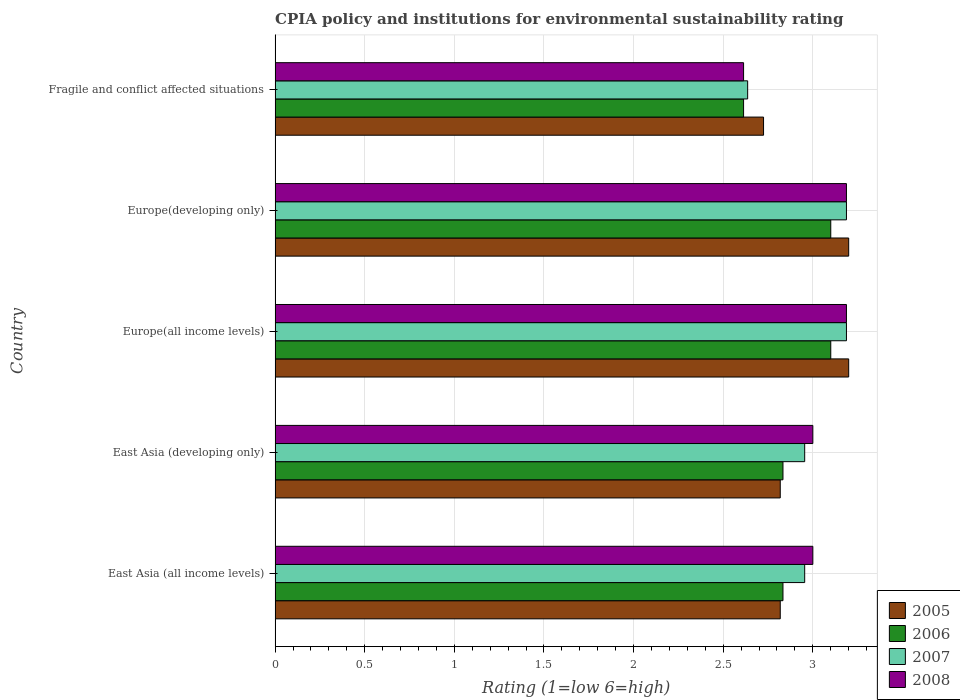How many groups of bars are there?
Provide a short and direct response. 5. Are the number of bars on each tick of the Y-axis equal?
Your response must be concise. Yes. How many bars are there on the 3rd tick from the bottom?
Provide a short and direct response. 4. What is the label of the 2nd group of bars from the top?
Your response must be concise. Europe(developing only). What is the CPIA rating in 2006 in Fragile and conflict affected situations?
Keep it short and to the point. 2.61. Across all countries, what is the maximum CPIA rating in 2006?
Offer a very short reply. 3.1. Across all countries, what is the minimum CPIA rating in 2006?
Provide a short and direct response. 2.61. In which country was the CPIA rating in 2007 maximum?
Provide a succinct answer. Europe(all income levels). In which country was the CPIA rating in 2005 minimum?
Offer a terse response. Fragile and conflict affected situations. What is the total CPIA rating in 2008 in the graph?
Keep it short and to the point. 14.99. What is the difference between the CPIA rating in 2007 in East Asia (developing only) and that in Fragile and conflict affected situations?
Provide a succinct answer. 0.32. What is the difference between the CPIA rating in 2005 in Europe(developing only) and the CPIA rating in 2008 in East Asia (all income levels)?
Ensure brevity in your answer.  0.2. What is the average CPIA rating in 2008 per country?
Your answer should be compact. 3. What is the difference between the CPIA rating in 2005 and CPIA rating in 2006 in East Asia (developing only)?
Your response must be concise. -0.02. What is the ratio of the CPIA rating in 2005 in East Asia (all income levels) to that in Europe(developing only)?
Offer a very short reply. 0.88. Is the CPIA rating in 2007 in East Asia (all income levels) less than that in Europe(developing only)?
Keep it short and to the point. Yes. Is the difference between the CPIA rating in 2005 in East Asia (developing only) and Fragile and conflict affected situations greater than the difference between the CPIA rating in 2006 in East Asia (developing only) and Fragile and conflict affected situations?
Your answer should be very brief. No. What is the difference between the highest and the second highest CPIA rating in 2006?
Make the answer very short. 0. What is the difference between the highest and the lowest CPIA rating in 2005?
Offer a very short reply. 0.48. In how many countries, is the CPIA rating in 2008 greater than the average CPIA rating in 2008 taken over all countries?
Provide a short and direct response. 4. Is the sum of the CPIA rating in 2005 in Europe(developing only) and Fragile and conflict affected situations greater than the maximum CPIA rating in 2008 across all countries?
Give a very brief answer. Yes. Is it the case that in every country, the sum of the CPIA rating in 2008 and CPIA rating in 2006 is greater than the sum of CPIA rating in 2007 and CPIA rating in 2005?
Provide a succinct answer. No. Are all the bars in the graph horizontal?
Offer a terse response. Yes. What is the difference between two consecutive major ticks on the X-axis?
Keep it short and to the point. 0.5. Are the values on the major ticks of X-axis written in scientific E-notation?
Provide a short and direct response. No. Does the graph contain any zero values?
Provide a succinct answer. No. Does the graph contain grids?
Your answer should be compact. Yes. Where does the legend appear in the graph?
Your answer should be very brief. Bottom right. How many legend labels are there?
Provide a short and direct response. 4. How are the legend labels stacked?
Offer a terse response. Vertical. What is the title of the graph?
Provide a short and direct response. CPIA policy and institutions for environmental sustainability rating. Does "1970" appear as one of the legend labels in the graph?
Offer a terse response. No. What is the label or title of the Y-axis?
Your answer should be very brief. Country. What is the Rating (1=low 6=high) in 2005 in East Asia (all income levels)?
Offer a terse response. 2.82. What is the Rating (1=low 6=high) of 2006 in East Asia (all income levels)?
Offer a very short reply. 2.83. What is the Rating (1=low 6=high) in 2007 in East Asia (all income levels)?
Make the answer very short. 2.95. What is the Rating (1=low 6=high) of 2005 in East Asia (developing only)?
Your answer should be very brief. 2.82. What is the Rating (1=low 6=high) in 2006 in East Asia (developing only)?
Your response must be concise. 2.83. What is the Rating (1=low 6=high) in 2007 in East Asia (developing only)?
Provide a short and direct response. 2.95. What is the Rating (1=low 6=high) of 2006 in Europe(all income levels)?
Your answer should be very brief. 3.1. What is the Rating (1=low 6=high) in 2007 in Europe(all income levels)?
Make the answer very short. 3.19. What is the Rating (1=low 6=high) in 2008 in Europe(all income levels)?
Provide a short and direct response. 3.19. What is the Rating (1=low 6=high) in 2007 in Europe(developing only)?
Your answer should be very brief. 3.19. What is the Rating (1=low 6=high) in 2008 in Europe(developing only)?
Provide a succinct answer. 3.19. What is the Rating (1=low 6=high) of 2005 in Fragile and conflict affected situations?
Provide a short and direct response. 2.73. What is the Rating (1=low 6=high) in 2006 in Fragile and conflict affected situations?
Provide a short and direct response. 2.61. What is the Rating (1=low 6=high) in 2007 in Fragile and conflict affected situations?
Provide a succinct answer. 2.64. What is the Rating (1=low 6=high) of 2008 in Fragile and conflict affected situations?
Your answer should be compact. 2.61. Across all countries, what is the maximum Rating (1=low 6=high) of 2007?
Make the answer very short. 3.19. Across all countries, what is the maximum Rating (1=low 6=high) of 2008?
Provide a short and direct response. 3.19. Across all countries, what is the minimum Rating (1=low 6=high) of 2005?
Make the answer very short. 2.73. Across all countries, what is the minimum Rating (1=low 6=high) of 2006?
Your response must be concise. 2.61. Across all countries, what is the minimum Rating (1=low 6=high) in 2007?
Your answer should be very brief. 2.64. Across all countries, what is the minimum Rating (1=low 6=high) in 2008?
Your answer should be very brief. 2.61. What is the total Rating (1=low 6=high) in 2005 in the graph?
Provide a succinct answer. 14.76. What is the total Rating (1=low 6=high) in 2006 in the graph?
Provide a short and direct response. 14.48. What is the total Rating (1=low 6=high) of 2007 in the graph?
Your answer should be compact. 14.92. What is the total Rating (1=low 6=high) of 2008 in the graph?
Give a very brief answer. 14.99. What is the difference between the Rating (1=low 6=high) in 2005 in East Asia (all income levels) and that in East Asia (developing only)?
Provide a succinct answer. 0. What is the difference between the Rating (1=low 6=high) of 2007 in East Asia (all income levels) and that in East Asia (developing only)?
Provide a succinct answer. 0. What is the difference between the Rating (1=low 6=high) of 2005 in East Asia (all income levels) and that in Europe(all income levels)?
Make the answer very short. -0.38. What is the difference between the Rating (1=low 6=high) of 2006 in East Asia (all income levels) and that in Europe(all income levels)?
Offer a very short reply. -0.27. What is the difference between the Rating (1=low 6=high) in 2007 in East Asia (all income levels) and that in Europe(all income levels)?
Provide a short and direct response. -0.23. What is the difference between the Rating (1=low 6=high) in 2008 in East Asia (all income levels) and that in Europe(all income levels)?
Keep it short and to the point. -0.19. What is the difference between the Rating (1=low 6=high) of 2005 in East Asia (all income levels) and that in Europe(developing only)?
Make the answer very short. -0.38. What is the difference between the Rating (1=low 6=high) in 2006 in East Asia (all income levels) and that in Europe(developing only)?
Keep it short and to the point. -0.27. What is the difference between the Rating (1=low 6=high) of 2007 in East Asia (all income levels) and that in Europe(developing only)?
Your answer should be compact. -0.23. What is the difference between the Rating (1=low 6=high) of 2008 in East Asia (all income levels) and that in Europe(developing only)?
Give a very brief answer. -0.19. What is the difference between the Rating (1=low 6=high) of 2005 in East Asia (all income levels) and that in Fragile and conflict affected situations?
Your answer should be very brief. 0.09. What is the difference between the Rating (1=low 6=high) of 2006 in East Asia (all income levels) and that in Fragile and conflict affected situations?
Keep it short and to the point. 0.22. What is the difference between the Rating (1=low 6=high) of 2007 in East Asia (all income levels) and that in Fragile and conflict affected situations?
Make the answer very short. 0.32. What is the difference between the Rating (1=low 6=high) in 2008 in East Asia (all income levels) and that in Fragile and conflict affected situations?
Ensure brevity in your answer.  0.39. What is the difference between the Rating (1=low 6=high) in 2005 in East Asia (developing only) and that in Europe(all income levels)?
Your response must be concise. -0.38. What is the difference between the Rating (1=low 6=high) of 2006 in East Asia (developing only) and that in Europe(all income levels)?
Keep it short and to the point. -0.27. What is the difference between the Rating (1=low 6=high) of 2007 in East Asia (developing only) and that in Europe(all income levels)?
Give a very brief answer. -0.23. What is the difference between the Rating (1=low 6=high) of 2008 in East Asia (developing only) and that in Europe(all income levels)?
Offer a terse response. -0.19. What is the difference between the Rating (1=low 6=high) in 2005 in East Asia (developing only) and that in Europe(developing only)?
Keep it short and to the point. -0.38. What is the difference between the Rating (1=low 6=high) in 2006 in East Asia (developing only) and that in Europe(developing only)?
Make the answer very short. -0.27. What is the difference between the Rating (1=low 6=high) in 2007 in East Asia (developing only) and that in Europe(developing only)?
Offer a very short reply. -0.23. What is the difference between the Rating (1=low 6=high) of 2008 in East Asia (developing only) and that in Europe(developing only)?
Make the answer very short. -0.19. What is the difference between the Rating (1=low 6=high) in 2005 in East Asia (developing only) and that in Fragile and conflict affected situations?
Provide a succinct answer. 0.09. What is the difference between the Rating (1=low 6=high) of 2006 in East Asia (developing only) and that in Fragile and conflict affected situations?
Your answer should be compact. 0.22. What is the difference between the Rating (1=low 6=high) in 2007 in East Asia (developing only) and that in Fragile and conflict affected situations?
Keep it short and to the point. 0.32. What is the difference between the Rating (1=low 6=high) in 2008 in East Asia (developing only) and that in Fragile and conflict affected situations?
Give a very brief answer. 0.39. What is the difference between the Rating (1=low 6=high) of 2005 in Europe(all income levels) and that in Europe(developing only)?
Provide a succinct answer. 0. What is the difference between the Rating (1=low 6=high) of 2007 in Europe(all income levels) and that in Europe(developing only)?
Your answer should be very brief. 0. What is the difference between the Rating (1=low 6=high) of 2008 in Europe(all income levels) and that in Europe(developing only)?
Make the answer very short. 0. What is the difference between the Rating (1=low 6=high) in 2005 in Europe(all income levels) and that in Fragile and conflict affected situations?
Make the answer very short. 0.47. What is the difference between the Rating (1=low 6=high) in 2006 in Europe(all income levels) and that in Fragile and conflict affected situations?
Your response must be concise. 0.49. What is the difference between the Rating (1=low 6=high) in 2007 in Europe(all income levels) and that in Fragile and conflict affected situations?
Your response must be concise. 0.55. What is the difference between the Rating (1=low 6=high) in 2008 in Europe(all income levels) and that in Fragile and conflict affected situations?
Provide a short and direct response. 0.57. What is the difference between the Rating (1=low 6=high) in 2005 in Europe(developing only) and that in Fragile and conflict affected situations?
Give a very brief answer. 0.47. What is the difference between the Rating (1=low 6=high) in 2006 in Europe(developing only) and that in Fragile and conflict affected situations?
Your answer should be very brief. 0.49. What is the difference between the Rating (1=low 6=high) of 2007 in Europe(developing only) and that in Fragile and conflict affected situations?
Make the answer very short. 0.55. What is the difference between the Rating (1=low 6=high) in 2008 in Europe(developing only) and that in Fragile and conflict affected situations?
Offer a very short reply. 0.57. What is the difference between the Rating (1=low 6=high) in 2005 in East Asia (all income levels) and the Rating (1=low 6=high) in 2006 in East Asia (developing only)?
Offer a very short reply. -0.02. What is the difference between the Rating (1=low 6=high) in 2005 in East Asia (all income levels) and the Rating (1=low 6=high) in 2007 in East Asia (developing only)?
Your answer should be very brief. -0.14. What is the difference between the Rating (1=low 6=high) of 2005 in East Asia (all income levels) and the Rating (1=low 6=high) of 2008 in East Asia (developing only)?
Make the answer very short. -0.18. What is the difference between the Rating (1=low 6=high) of 2006 in East Asia (all income levels) and the Rating (1=low 6=high) of 2007 in East Asia (developing only)?
Your answer should be very brief. -0.12. What is the difference between the Rating (1=low 6=high) in 2006 in East Asia (all income levels) and the Rating (1=low 6=high) in 2008 in East Asia (developing only)?
Your answer should be compact. -0.17. What is the difference between the Rating (1=low 6=high) in 2007 in East Asia (all income levels) and the Rating (1=low 6=high) in 2008 in East Asia (developing only)?
Offer a terse response. -0.05. What is the difference between the Rating (1=low 6=high) of 2005 in East Asia (all income levels) and the Rating (1=low 6=high) of 2006 in Europe(all income levels)?
Your answer should be compact. -0.28. What is the difference between the Rating (1=low 6=high) of 2005 in East Asia (all income levels) and the Rating (1=low 6=high) of 2007 in Europe(all income levels)?
Your answer should be compact. -0.37. What is the difference between the Rating (1=low 6=high) in 2005 in East Asia (all income levels) and the Rating (1=low 6=high) in 2008 in Europe(all income levels)?
Offer a terse response. -0.37. What is the difference between the Rating (1=low 6=high) of 2006 in East Asia (all income levels) and the Rating (1=low 6=high) of 2007 in Europe(all income levels)?
Ensure brevity in your answer.  -0.35. What is the difference between the Rating (1=low 6=high) of 2006 in East Asia (all income levels) and the Rating (1=low 6=high) of 2008 in Europe(all income levels)?
Your response must be concise. -0.35. What is the difference between the Rating (1=low 6=high) in 2007 in East Asia (all income levels) and the Rating (1=low 6=high) in 2008 in Europe(all income levels)?
Provide a short and direct response. -0.23. What is the difference between the Rating (1=low 6=high) of 2005 in East Asia (all income levels) and the Rating (1=low 6=high) of 2006 in Europe(developing only)?
Make the answer very short. -0.28. What is the difference between the Rating (1=low 6=high) of 2005 in East Asia (all income levels) and the Rating (1=low 6=high) of 2007 in Europe(developing only)?
Your response must be concise. -0.37. What is the difference between the Rating (1=low 6=high) of 2005 in East Asia (all income levels) and the Rating (1=low 6=high) of 2008 in Europe(developing only)?
Keep it short and to the point. -0.37. What is the difference between the Rating (1=low 6=high) of 2006 in East Asia (all income levels) and the Rating (1=low 6=high) of 2007 in Europe(developing only)?
Your response must be concise. -0.35. What is the difference between the Rating (1=low 6=high) in 2006 in East Asia (all income levels) and the Rating (1=low 6=high) in 2008 in Europe(developing only)?
Your answer should be compact. -0.35. What is the difference between the Rating (1=low 6=high) in 2007 in East Asia (all income levels) and the Rating (1=low 6=high) in 2008 in Europe(developing only)?
Ensure brevity in your answer.  -0.23. What is the difference between the Rating (1=low 6=high) in 2005 in East Asia (all income levels) and the Rating (1=low 6=high) in 2006 in Fragile and conflict affected situations?
Your answer should be very brief. 0.2. What is the difference between the Rating (1=low 6=high) of 2005 in East Asia (all income levels) and the Rating (1=low 6=high) of 2007 in Fragile and conflict affected situations?
Ensure brevity in your answer.  0.18. What is the difference between the Rating (1=low 6=high) of 2005 in East Asia (all income levels) and the Rating (1=low 6=high) of 2008 in Fragile and conflict affected situations?
Your answer should be compact. 0.2. What is the difference between the Rating (1=low 6=high) of 2006 in East Asia (all income levels) and the Rating (1=low 6=high) of 2007 in Fragile and conflict affected situations?
Make the answer very short. 0.2. What is the difference between the Rating (1=low 6=high) in 2006 in East Asia (all income levels) and the Rating (1=low 6=high) in 2008 in Fragile and conflict affected situations?
Offer a very short reply. 0.22. What is the difference between the Rating (1=low 6=high) of 2007 in East Asia (all income levels) and the Rating (1=low 6=high) of 2008 in Fragile and conflict affected situations?
Provide a succinct answer. 0.34. What is the difference between the Rating (1=low 6=high) of 2005 in East Asia (developing only) and the Rating (1=low 6=high) of 2006 in Europe(all income levels)?
Ensure brevity in your answer.  -0.28. What is the difference between the Rating (1=low 6=high) of 2005 in East Asia (developing only) and the Rating (1=low 6=high) of 2007 in Europe(all income levels)?
Your answer should be very brief. -0.37. What is the difference between the Rating (1=low 6=high) of 2005 in East Asia (developing only) and the Rating (1=low 6=high) of 2008 in Europe(all income levels)?
Keep it short and to the point. -0.37. What is the difference between the Rating (1=low 6=high) of 2006 in East Asia (developing only) and the Rating (1=low 6=high) of 2007 in Europe(all income levels)?
Your answer should be very brief. -0.35. What is the difference between the Rating (1=low 6=high) of 2006 in East Asia (developing only) and the Rating (1=low 6=high) of 2008 in Europe(all income levels)?
Offer a terse response. -0.35. What is the difference between the Rating (1=low 6=high) of 2007 in East Asia (developing only) and the Rating (1=low 6=high) of 2008 in Europe(all income levels)?
Give a very brief answer. -0.23. What is the difference between the Rating (1=low 6=high) in 2005 in East Asia (developing only) and the Rating (1=low 6=high) in 2006 in Europe(developing only)?
Your answer should be very brief. -0.28. What is the difference between the Rating (1=low 6=high) in 2005 in East Asia (developing only) and the Rating (1=low 6=high) in 2007 in Europe(developing only)?
Your answer should be compact. -0.37. What is the difference between the Rating (1=low 6=high) of 2005 in East Asia (developing only) and the Rating (1=low 6=high) of 2008 in Europe(developing only)?
Offer a very short reply. -0.37. What is the difference between the Rating (1=low 6=high) of 2006 in East Asia (developing only) and the Rating (1=low 6=high) of 2007 in Europe(developing only)?
Provide a succinct answer. -0.35. What is the difference between the Rating (1=low 6=high) in 2006 in East Asia (developing only) and the Rating (1=low 6=high) in 2008 in Europe(developing only)?
Keep it short and to the point. -0.35. What is the difference between the Rating (1=low 6=high) in 2007 in East Asia (developing only) and the Rating (1=low 6=high) in 2008 in Europe(developing only)?
Provide a succinct answer. -0.23. What is the difference between the Rating (1=low 6=high) of 2005 in East Asia (developing only) and the Rating (1=low 6=high) of 2006 in Fragile and conflict affected situations?
Your answer should be compact. 0.2. What is the difference between the Rating (1=low 6=high) in 2005 in East Asia (developing only) and the Rating (1=low 6=high) in 2007 in Fragile and conflict affected situations?
Give a very brief answer. 0.18. What is the difference between the Rating (1=low 6=high) of 2005 in East Asia (developing only) and the Rating (1=low 6=high) of 2008 in Fragile and conflict affected situations?
Your answer should be very brief. 0.2. What is the difference between the Rating (1=low 6=high) of 2006 in East Asia (developing only) and the Rating (1=low 6=high) of 2007 in Fragile and conflict affected situations?
Offer a terse response. 0.2. What is the difference between the Rating (1=low 6=high) in 2006 in East Asia (developing only) and the Rating (1=low 6=high) in 2008 in Fragile and conflict affected situations?
Ensure brevity in your answer.  0.22. What is the difference between the Rating (1=low 6=high) in 2007 in East Asia (developing only) and the Rating (1=low 6=high) in 2008 in Fragile and conflict affected situations?
Your response must be concise. 0.34. What is the difference between the Rating (1=low 6=high) of 2005 in Europe(all income levels) and the Rating (1=low 6=high) of 2007 in Europe(developing only)?
Make the answer very short. 0.01. What is the difference between the Rating (1=low 6=high) in 2005 in Europe(all income levels) and the Rating (1=low 6=high) in 2008 in Europe(developing only)?
Offer a terse response. 0.01. What is the difference between the Rating (1=low 6=high) in 2006 in Europe(all income levels) and the Rating (1=low 6=high) in 2007 in Europe(developing only)?
Provide a short and direct response. -0.09. What is the difference between the Rating (1=low 6=high) of 2006 in Europe(all income levels) and the Rating (1=low 6=high) of 2008 in Europe(developing only)?
Provide a succinct answer. -0.09. What is the difference between the Rating (1=low 6=high) of 2007 in Europe(all income levels) and the Rating (1=low 6=high) of 2008 in Europe(developing only)?
Make the answer very short. 0. What is the difference between the Rating (1=low 6=high) of 2005 in Europe(all income levels) and the Rating (1=low 6=high) of 2006 in Fragile and conflict affected situations?
Your answer should be very brief. 0.59. What is the difference between the Rating (1=low 6=high) of 2005 in Europe(all income levels) and the Rating (1=low 6=high) of 2007 in Fragile and conflict affected situations?
Provide a succinct answer. 0.56. What is the difference between the Rating (1=low 6=high) in 2005 in Europe(all income levels) and the Rating (1=low 6=high) in 2008 in Fragile and conflict affected situations?
Offer a terse response. 0.59. What is the difference between the Rating (1=low 6=high) in 2006 in Europe(all income levels) and the Rating (1=low 6=high) in 2007 in Fragile and conflict affected situations?
Offer a very short reply. 0.46. What is the difference between the Rating (1=low 6=high) in 2006 in Europe(all income levels) and the Rating (1=low 6=high) in 2008 in Fragile and conflict affected situations?
Ensure brevity in your answer.  0.49. What is the difference between the Rating (1=low 6=high) in 2007 in Europe(all income levels) and the Rating (1=low 6=high) in 2008 in Fragile and conflict affected situations?
Provide a short and direct response. 0.57. What is the difference between the Rating (1=low 6=high) of 2005 in Europe(developing only) and the Rating (1=low 6=high) of 2006 in Fragile and conflict affected situations?
Your answer should be very brief. 0.59. What is the difference between the Rating (1=low 6=high) in 2005 in Europe(developing only) and the Rating (1=low 6=high) in 2007 in Fragile and conflict affected situations?
Keep it short and to the point. 0.56. What is the difference between the Rating (1=low 6=high) in 2005 in Europe(developing only) and the Rating (1=low 6=high) in 2008 in Fragile and conflict affected situations?
Provide a short and direct response. 0.59. What is the difference between the Rating (1=low 6=high) in 2006 in Europe(developing only) and the Rating (1=low 6=high) in 2007 in Fragile and conflict affected situations?
Offer a terse response. 0.46. What is the difference between the Rating (1=low 6=high) of 2006 in Europe(developing only) and the Rating (1=low 6=high) of 2008 in Fragile and conflict affected situations?
Ensure brevity in your answer.  0.49. What is the difference between the Rating (1=low 6=high) of 2007 in Europe(developing only) and the Rating (1=low 6=high) of 2008 in Fragile and conflict affected situations?
Offer a very short reply. 0.57. What is the average Rating (1=low 6=high) of 2005 per country?
Ensure brevity in your answer.  2.95. What is the average Rating (1=low 6=high) in 2006 per country?
Provide a short and direct response. 2.9. What is the average Rating (1=low 6=high) in 2007 per country?
Provide a succinct answer. 2.98. What is the average Rating (1=low 6=high) in 2008 per country?
Offer a very short reply. 3. What is the difference between the Rating (1=low 6=high) of 2005 and Rating (1=low 6=high) of 2006 in East Asia (all income levels)?
Your answer should be very brief. -0.02. What is the difference between the Rating (1=low 6=high) of 2005 and Rating (1=low 6=high) of 2007 in East Asia (all income levels)?
Offer a terse response. -0.14. What is the difference between the Rating (1=low 6=high) in 2005 and Rating (1=low 6=high) in 2008 in East Asia (all income levels)?
Keep it short and to the point. -0.18. What is the difference between the Rating (1=low 6=high) of 2006 and Rating (1=low 6=high) of 2007 in East Asia (all income levels)?
Give a very brief answer. -0.12. What is the difference between the Rating (1=low 6=high) of 2007 and Rating (1=low 6=high) of 2008 in East Asia (all income levels)?
Make the answer very short. -0.05. What is the difference between the Rating (1=low 6=high) in 2005 and Rating (1=low 6=high) in 2006 in East Asia (developing only)?
Your answer should be very brief. -0.02. What is the difference between the Rating (1=low 6=high) in 2005 and Rating (1=low 6=high) in 2007 in East Asia (developing only)?
Give a very brief answer. -0.14. What is the difference between the Rating (1=low 6=high) in 2005 and Rating (1=low 6=high) in 2008 in East Asia (developing only)?
Provide a short and direct response. -0.18. What is the difference between the Rating (1=low 6=high) in 2006 and Rating (1=low 6=high) in 2007 in East Asia (developing only)?
Give a very brief answer. -0.12. What is the difference between the Rating (1=low 6=high) of 2006 and Rating (1=low 6=high) of 2008 in East Asia (developing only)?
Your answer should be compact. -0.17. What is the difference between the Rating (1=low 6=high) in 2007 and Rating (1=low 6=high) in 2008 in East Asia (developing only)?
Give a very brief answer. -0.05. What is the difference between the Rating (1=low 6=high) of 2005 and Rating (1=low 6=high) of 2006 in Europe(all income levels)?
Give a very brief answer. 0.1. What is the difference between the Rating (1=low 6=high) in 2005 and Rating (1=low 6=high) in 2007 in Europe(all income levels)?
Keep it short and to the point. 0.01. What is the difference between the Rating (1=low 6=high) in 2005 and Rating (1=low 6=high) in 2008 in Europe(all income levels)?
Offer a very short reply. 0.01. What is the difference between the Rating (1=low 6=high) of 2006 and Rating (1=low 6=high) of 2007 in Europe(all income levels)?
Provide a succinct answer. -0.09. What is the difference between the Rating (1=low 6=high) in 2006 and Rating (1=low 6=high) in 2008 in Europe(all income levels)?
Make the answer very short. -0.09. What is the difference between the Rating (1=low 6=high) of 2007 and Rating (1=low 6=high) of 2008 in Europe(all income levels)?
Ensure brevity in your answer.  0. What is the difference between the Rating (1=low 6=high) of 2005 and Rating (1=low 6=high) of 2007 in Europe(developing only)?
Make the answer very short. 0.01. What is the difference between the Rating (1=low 6=high) of 2005 and Rating (1=low 6=high) of 2008 in Europe(developing only)?
Keep it short and to the point. 0.01. What is the difference between the Rating (1=low 6=high) in 2006 and Rating (1=low 6=high) in 2007 in Europe(developing only)?
Provide a short and direct response. -0.09. What is the difference between the Rating (1=low 6=high) in 2006 and Rating (1=low 6=high) in 2008 in Europe(developing only)?
Offer a very short reply. -0.09. What is the difference between the Rating (1=low 6=high) of 2007 and Rating (1=low 6=high) of 2008 in Europe(developing only)?
Keep it short and to the point. 0. What is the difference between the Rating (1=low 6=high) of 2005 and Rating (1=low 6=high) of 2006 in Fragile and conflict affected situations?
Your answer should be compact. 0.11. What is the difference between the Rating (1=low 6=high) in 2005 and Rating (1=low 6=high) in 2007 in Fragile and conflict affected situations?
Your response must be concise. 0.09. What is the difference between the Rating (1=low 6=high) in 2005 and Rating (1=low 6=high) in 2008 in Fragile and conflict affected situations?
Provide a short and direct response. 0.11. What is the difference between the Rating (1=low 6=high) in 2006 and Rating (1=low 6=high) in 2007 in Fragile and conflict affected situations?
Offer a very short reply. -0.02. What is the difference between the Rating (1=low 6=high) of 2006 and Rating (1=low 6=high) of 2008 in Fragile and conflict affected situations?
Keep it short and to the point. 0. What is the difference between the Rating (1=low 6=high) in 2007 and Rating (1=low 6=high) in 2008 in Fragile and conflict affected situations?
Keep it short and to the point. 0.02. What is the ratio of the Rating (1=low 6=high) of 2005 in East Asia (all income levels) to that in East Asia (developing only)?
Make the answer very short. 1. What is the ratio of the Rating (1=low 6=high) of 2006 in East Asia (all income levels) to that in East Asia (developing only)?
Make the answer very short. 1. What is the ratio of the Rating (1=low 6=high) of 2005 in East Asia (all income levels) to that in Europe(all income levels)?
Offer a very short reply. 0.88. What is the ratio of the Rating (1=low 6=high) in 2006 in East Asia (all income levels) to that in Europe(all income levels)?
Provide a short and direct response. 0.91. What is the ratio of the Rating (1=low 6=high) in 2007 in East Asia (all income levels) to that in Europe(all income levels)?
Your answer should be very brief. 0.93. What is the ratio of the Rating (1=low 6=high) in 2005 in East Asia (all income levels) to that in Europe(developing only)?
Offer a terse response. 0.88. What is the ratio of the Rating (1=low 6=high) of 2006 in East Asia (all income levels) to that in Europe(developing only)?
Offer a terse response. 0.91. What is the ratio of the Rating (1=low 6=high) of 2007 in East Asia (all income levels) to that in Europe(developing only)?
Offer a very short reply. 0.93. What is the ratio of the Rating (1=low 6=high) in 2008 in East Asia (all income levels) to that in Europe(developing only)?
Offer a very short reply. 0.94. What is the ratio of the Rating (1=low 6=high) in 2005 in East Asia (all income levels) to that in Fragile and conflict affected situations?
Your answer should be compact. 1.03. What is the ratio of the Rating (1=low 6=high) of 2006 in East Asia (all income levels) to that in Fragile and conflict affected situations?
Provide a succinct answer. 1.08. What is the ratio of the Rating (1=low 6=high) in 2007 in East Asia (all income levels) to that in Fragile and conflict affected situations?
Give a very brief answer. 1.12. What is the ratio of the Rating (1=low 6=high) of 2008 in East Asia (all income levels) to that in Fragile and conflict affected situations?
Your answer should be compact. 1.15. What is the ratio of the Rating (1=low 6=high) in 2005 in East Asia (developing only) to that in Europe(all income levels)?
Ensure brevity in your answer.  0.88. What is the ratio of the Rating (1=low 6=high) of 2006 in East Asia (developing only) to that in Europe(all income levels)?
Provide a succinct answer. 0.91. What is the ratio of the Rating (1=low 6=high) in 2007 in East Asia (developing only) to that in Europe(all income levels)?
Provide a succinct answer. 0.93. What is the ratio of the Rating (1=low 6=high) of 2005 in East Asia (developing only) to that in Europe(developing only)?
Your answer should be very brief. 0.88. What is the ratio of the Rating (1=low 6=high) of 2006 in East Asia (developing only) to that in Europe(developing only)?
Your response must be concise. 0.91. What is the ratio of the Rating (1=low 6=high) in 2007 in East Asia (developing only) to that in Europe(developing only)?
Provide a succinct answer. 0.93. What is the ratio of the Rating (1=low 6=high) of 2008 in East Asia (developing only) to that in Europe(developing only)?
Keep it short and to the point. 0.94. What is the ratio of the Rating (1=low 6=high) in 2005 in East Asia (developing only) to that in Fragile and conflict affected situations?
Offer a very short reply. 1.03. What is the ratio of the Rating (1=low 6=high) of 2006 in East Asia (developing only) to that in Fragile and conflict affected situations?
Your answer should be very brief. 1.08. What is the ratio of the Rating (1=low 6=high) of 2007 in East Asia (developing only) to that in Fragile and conflict affected situations?
Keep it short and to the point. 1.12. What is the ratio of the Rating (1=low 6=high) in 2008 in East Asia (developing only) to that in Fragile and conflict affected situations?
Make the answer very short. 1.15. What is the ratio of the Rating (1=low 6=high) of 2006 in Europe(all income levels) to that in Europe(developing only)?
Offer a very short reply. 1. What is the ratio of the Rating (1=low 6=high) in 2005 in Europe(all income levels) to that in Fragile and conflict affected situations?
Provide a succinct answer. 1.17. What is the ratio of the Rating (1=low 6=high) in 2006 in Europe(all income levels) to that in Fragile and conflict affected situations?
Provide a succinct answer. 1.19. What is the ratio of the Rating (1=low 6=high) of 2007 in Europe(all income levels) to that in Fragile and conflict affected situations?
Ensure brevity in your answer.  1.21. What is the ratio of the Rating (1=low 6=high) of 2008 in Europe(all income levels) to that in Fragile and conflict affected situations?
Ensure brevity in your answer.  1.22. What is the ratio of the Rating (1=low 6=high) of 2005 in Europe(developing only) to that in Fragile and conflict affected situations?
Offer a terse response. 1.17. What is the ratio of the Rating (1=low 6=high) in 2006 in Europe(developing only) to that in Fragile and conflict affected situations?
Your response must be concise. 1.19. What is the ratio of the Rating (1=low 6=high) of 2007 in Europe(developing only) to that in Fragile and conflict affected situations?
Your response must be concise. 1.21. What is the ratio of the Rating (1=low 6=high) of 2008 in Europe(developing only) to that in Fragile and conflict affected situations?
Give a very brief answer. 1.22. What is the difference between the highest and the second highest Rating (1=low 6=high) in 2005?
Make the answer very short. 0. What is the difference between the highest and the second highest Rating (1=low 6=high) of 2007?
Your answer should be compact. 0. What is the difference between the highest and the lowest Rating (1=low 6=high) of 2005?
Offer a terse response. 0.47. What is the difference between the highest and the lowest Rating (1=low 6=high) in 2006?
Make the answer very short. 0.49. What is the difference between the highest and the lowest Rating (1=low 6=high) in 2007?
Provide a succinct answer. 0.55. What is the difference between the highest and the lowest Rating (1=low 6=high) of 2008?
Provide a succinct answer. 0.57. 